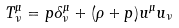<formula> <loc_0><loc_0><loc_500><loc_500>T ^ { \mu } _ { \nu } = p \delta ^ { \mu } _ { \nu } + ( \rho + p ) u ^ { \mu } u _ { \nu }</formula> 